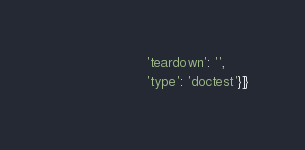<code> <loc_0><loc_0><loc_500><loc_500><_Python_>                      'teardown': '',
                      'type': 'doctest'}]}
</code> 